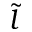Convert formula to latex. <formula><loc_0><loc_0><loc_500><loc_500>\tilde { l }</formula> 